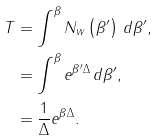<formula> <loc_0><loc_0><loc_500><loc_500>T & = \int ^ { \beta } N _ { w } \left ( \beta ^ { \prime } \right ) \, d \beta ^ { \prime } , \\ & = \int ^ { \beta } e ^ { \beta ^ { \prime } \Delta } \, d \beta ^ { \prime } , \\ & = \frac { 1 } { \Delta } e ^ { \beta \Delta } .</formula> 